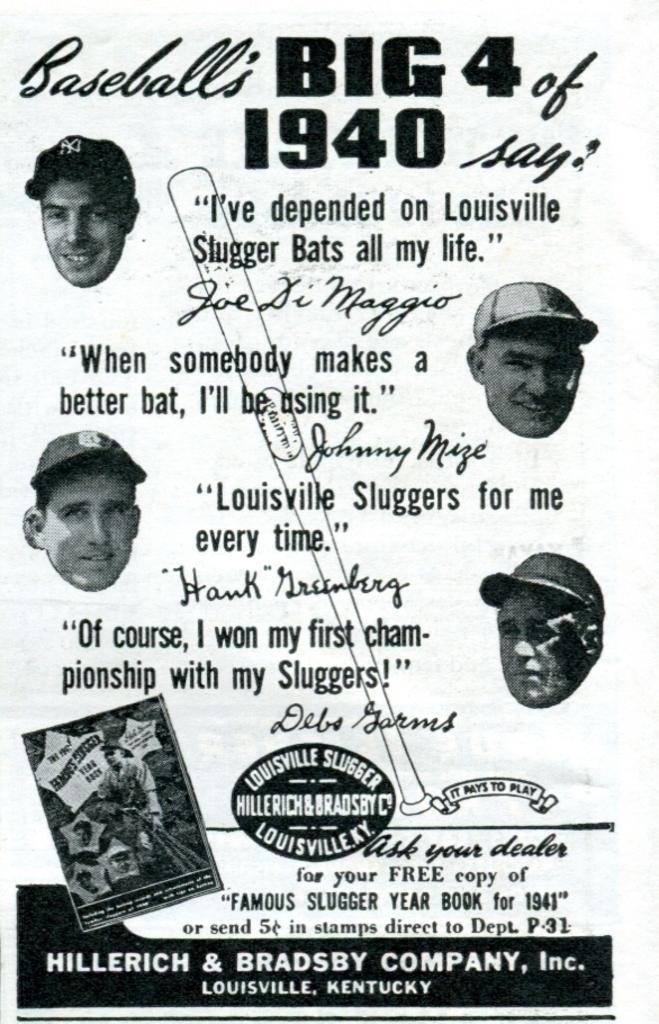What type of visual is the image in question? The image is a poster. What can be seen on the poster? There are images of people on the poster. Are there any words on the poster? Yes, there is text on the poster. Are there any numbers on the poster? Yes, there are numbers on the poster. Can you describe any other elements on the poster? There are other unspecified elements on the poster. What type of noise can be heard coming from the sack in the image? There is no sack or noise present in the image, as it is a poster with images of people, text, numbers, and other unspecified elements. 